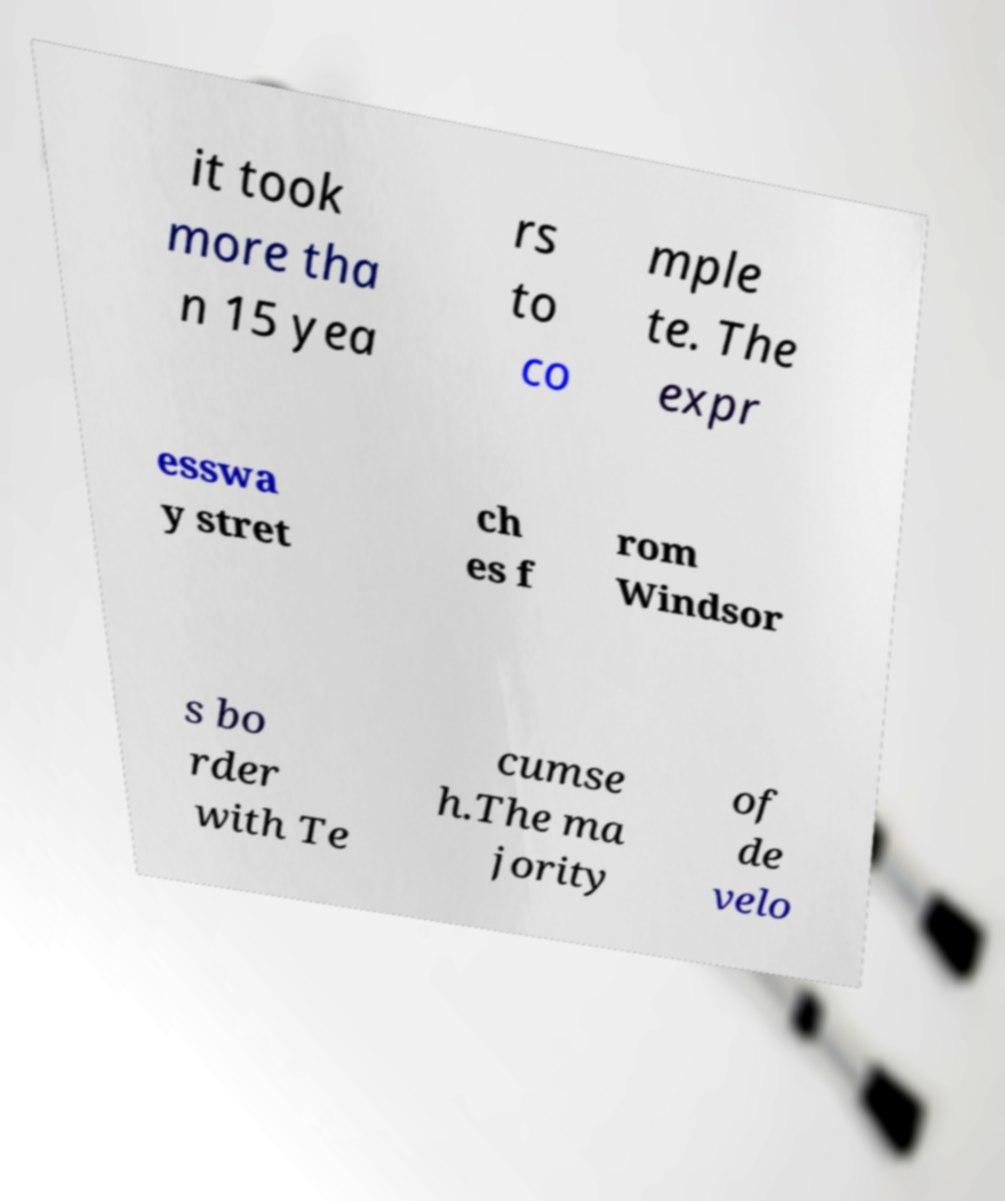Please identify and transcribe the text found in this image. it took more tha n 15 yea rs to co mple te. The expr esswa y stret ch es f rom Windsor s bo rder with Te cumse h.The ma jority of de velo 